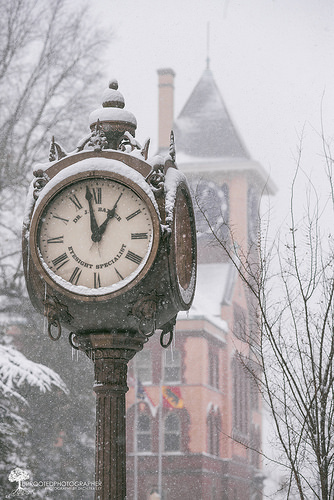<image>
Can you confirm if the clock is under the snow tree? Yes. The clock is positioned underneath the snow tree, with the snow tree above it in the vertical space. 